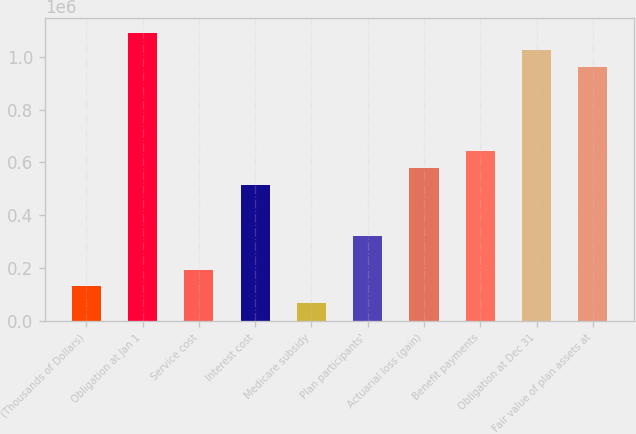<chart> <loc_0><loc_0><loc_500><loc_500><bar_chart><fcel>(Thousands of Dollars)<fcel>Obligation at Jan 1<fcel>Service cost<fcel>Interest cost<fcel>Medicare subsidy<fcel>Plan participants'<fcel>Actuarial loss (gain)<fcel>Benefit payments<fcel>Obligation at Dec 31<fcel>Fair value of plan assets at<nl><fcel>130030<fcel>1.0916e+06<fcel>194135<fcel>514659<fcel>65924.9<fcel>322344<fcel>578764<fcel>642869<fcel>1.0275e+06<fcel>963394<nl></chart> 